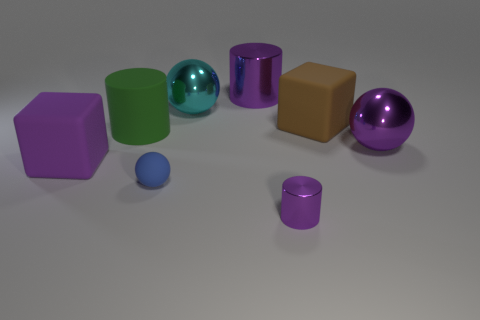Is the tiny purple object made of the same material as the big brown object?
Make the answer very short. No. How many cylinders are green objects or purple matte things?
Provide a short and direct response. 1. There is a big cylinder that is made of the same material as the cyan object; what color is it?
Offer a terse response. Purple. Are there fewer large matte blocks than big purple spheres?
Make the answer very short. No. There is a big matte object to the right of the big purple shiny cylinder; is its shape the same as the purple object behind the purple ball?
Your response must be concise. No. How many objects are brown cubes or big green cylinders?
Provide a short and direct response. 2. There is a metal thing that is the same size as the blue rubber sphere; what color is it?
Provide a succinct answer. Purple. There is a cube left of the small blue ball; what number of big shiny cylinders are on the left side of it?
Give a very brief answer. 0. How many objects are behind the blue matte ball and to the left of the large cyan metal sphere?
Your answer should be compact. 2. What number of things are either big cubes right of the tiny shiny thing or purple objects behind the small purple thing?
Offer a terse response. 4. 